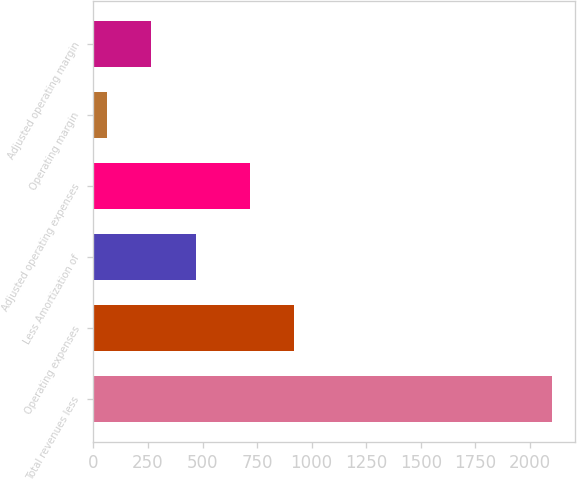<chart> <loc_0><loc_0><loc_500><loc_500><bar_chart><fcel>Total revenues less<fcel>Operating expenses<fcel>Less Amortization of<fcel>Adjusted operating expenses<fcel>Operating margin<fcel>Adjusted operating margin<nl><fcel>2102<fcel>920.1<fcel>469.2<fcel>716<fcel>61<fcel>265.1<nl></chart> 